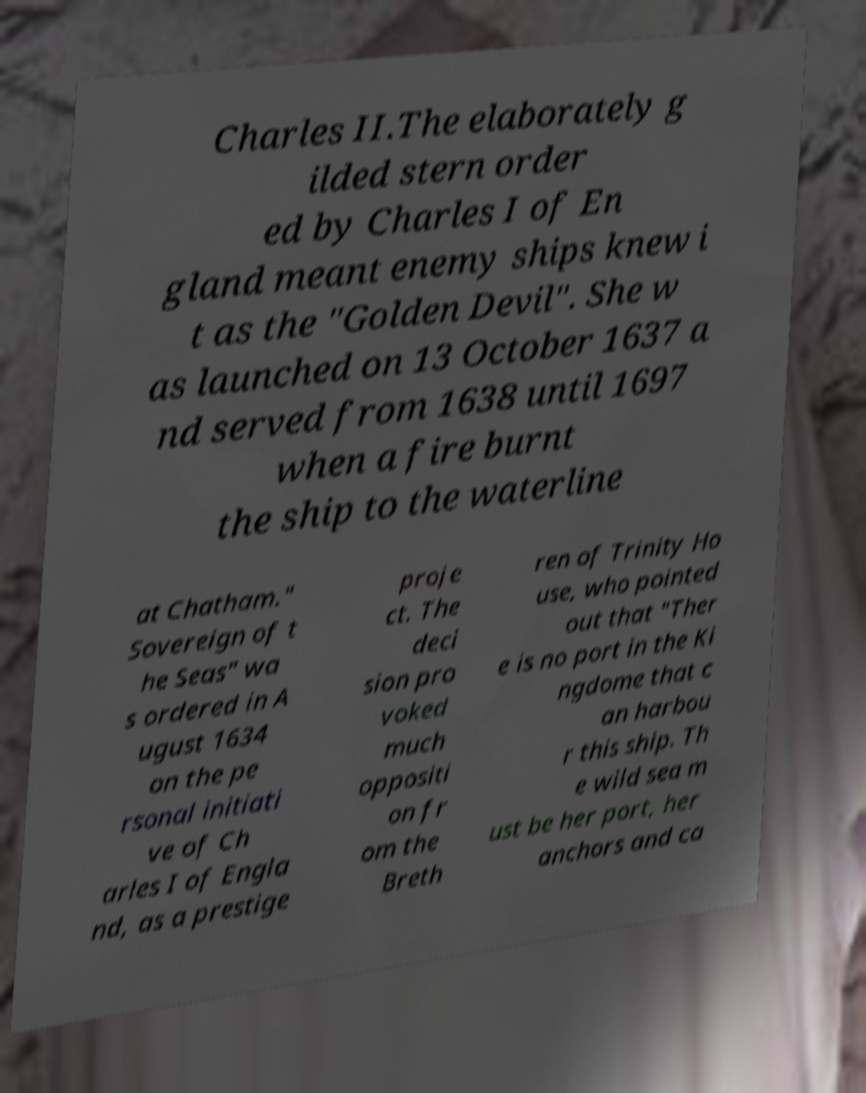I need the written content from this picture converted into text. Can you do that? Charles II.The elaborately g ilded stern order ed by Charles I of En gland meant enemy ships knew i t as the "Golden Devil". She w as launched on 13 October 1637 a nd served from 1638 until 1697 when a fire burnt the ship to the waterline at Chatham." Sovereign of t he Seas" wa s ordered in A ugust 1634 on the pe rsonal initiati ve of Ch arles I of Engla nd, as a prestige proje ct. The deci sion pro voked much oppositi on fr om the Breth ren of Trinity Ho use, who pointed out that "Ther e is no port in the Ki ngdome that c an harbou r this ship. Th e wild sea m ust be her port, her anchors and ca 